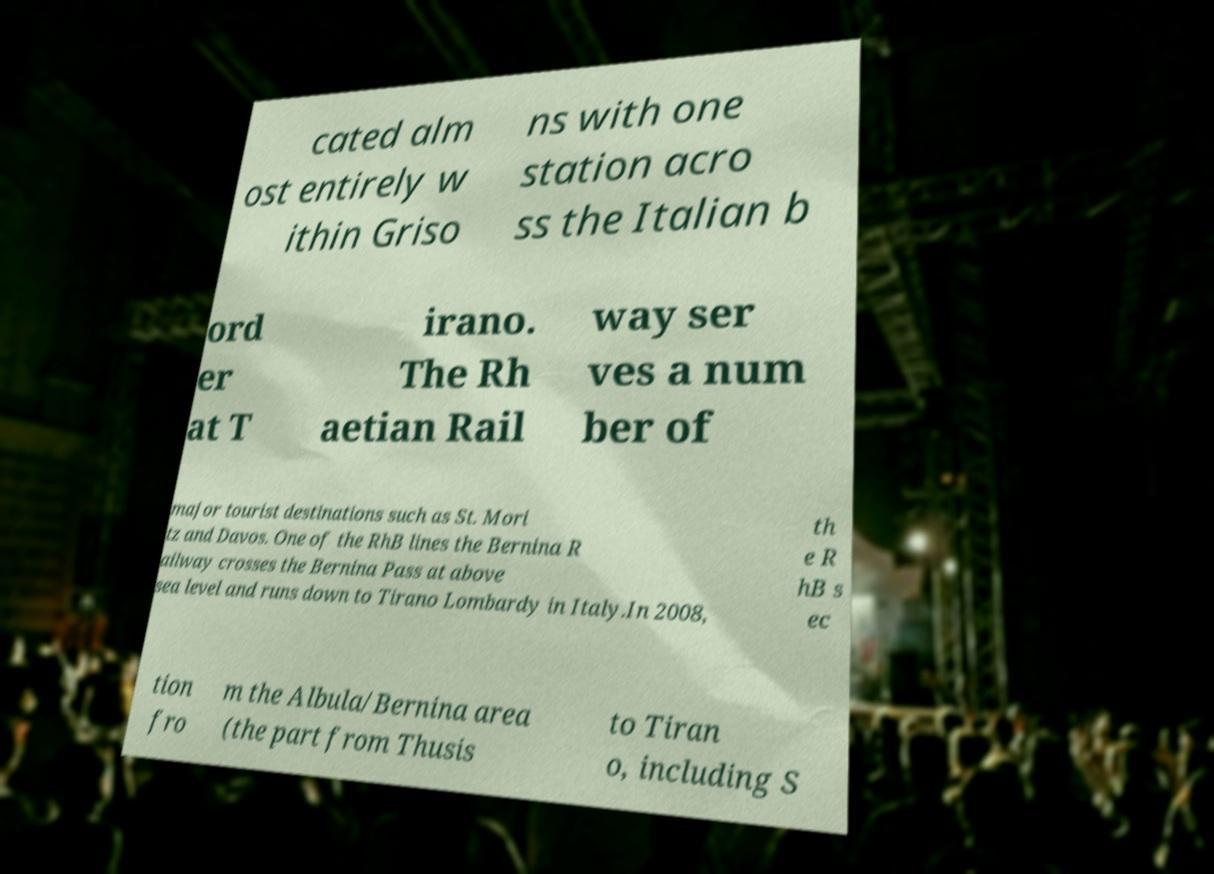Can you read and provide the text displayed in the image?This photo seems to have some interesting text. Can you extract and type it out for me? cated alm ost entirely w ithin Griso ns with one station acro ss the Italian b ord er at T irano. The Rh aetian Rail way ser ves a num ber of major tourist destinations such as St. Mori tz and Davos. One of the RhB lines the Bernina R ailway crosses the Bernina Pass at above sea level and runs down to Tirano Lombardy in Italy.In 2008, th e R hB s ec tion fro m the Albula/Bernina area (the part from Thusis to Tiran o, including S 